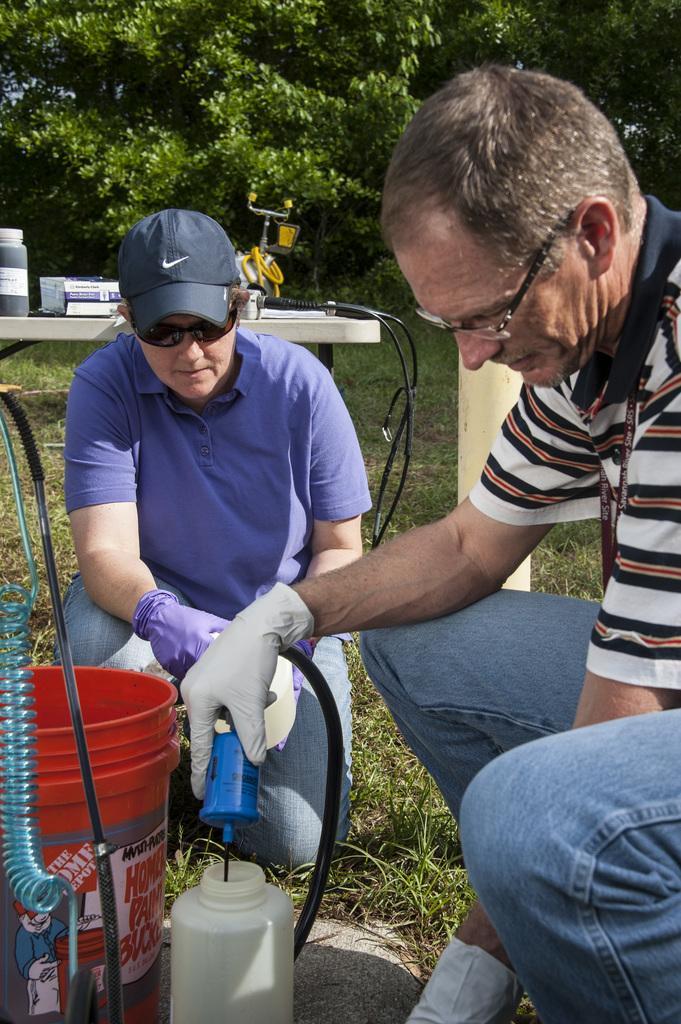In one or two sentences, can you explain what this image depicts? On the right side there is a person wearing specs and gloves is holding something in the hand. Also there is another person wearing cap, goggles and gloves. In front of them there is a bucket and a bottle. On the ground there is grass. In the back there is table. On that there is a bottle and some other things. In the background there are trees. 